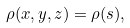Convert formula to latex. <formula><loc_0><loc_0><loc_500><loc_500>\rho ( x , y , z ) = \rho ( s ) ,</formula> 